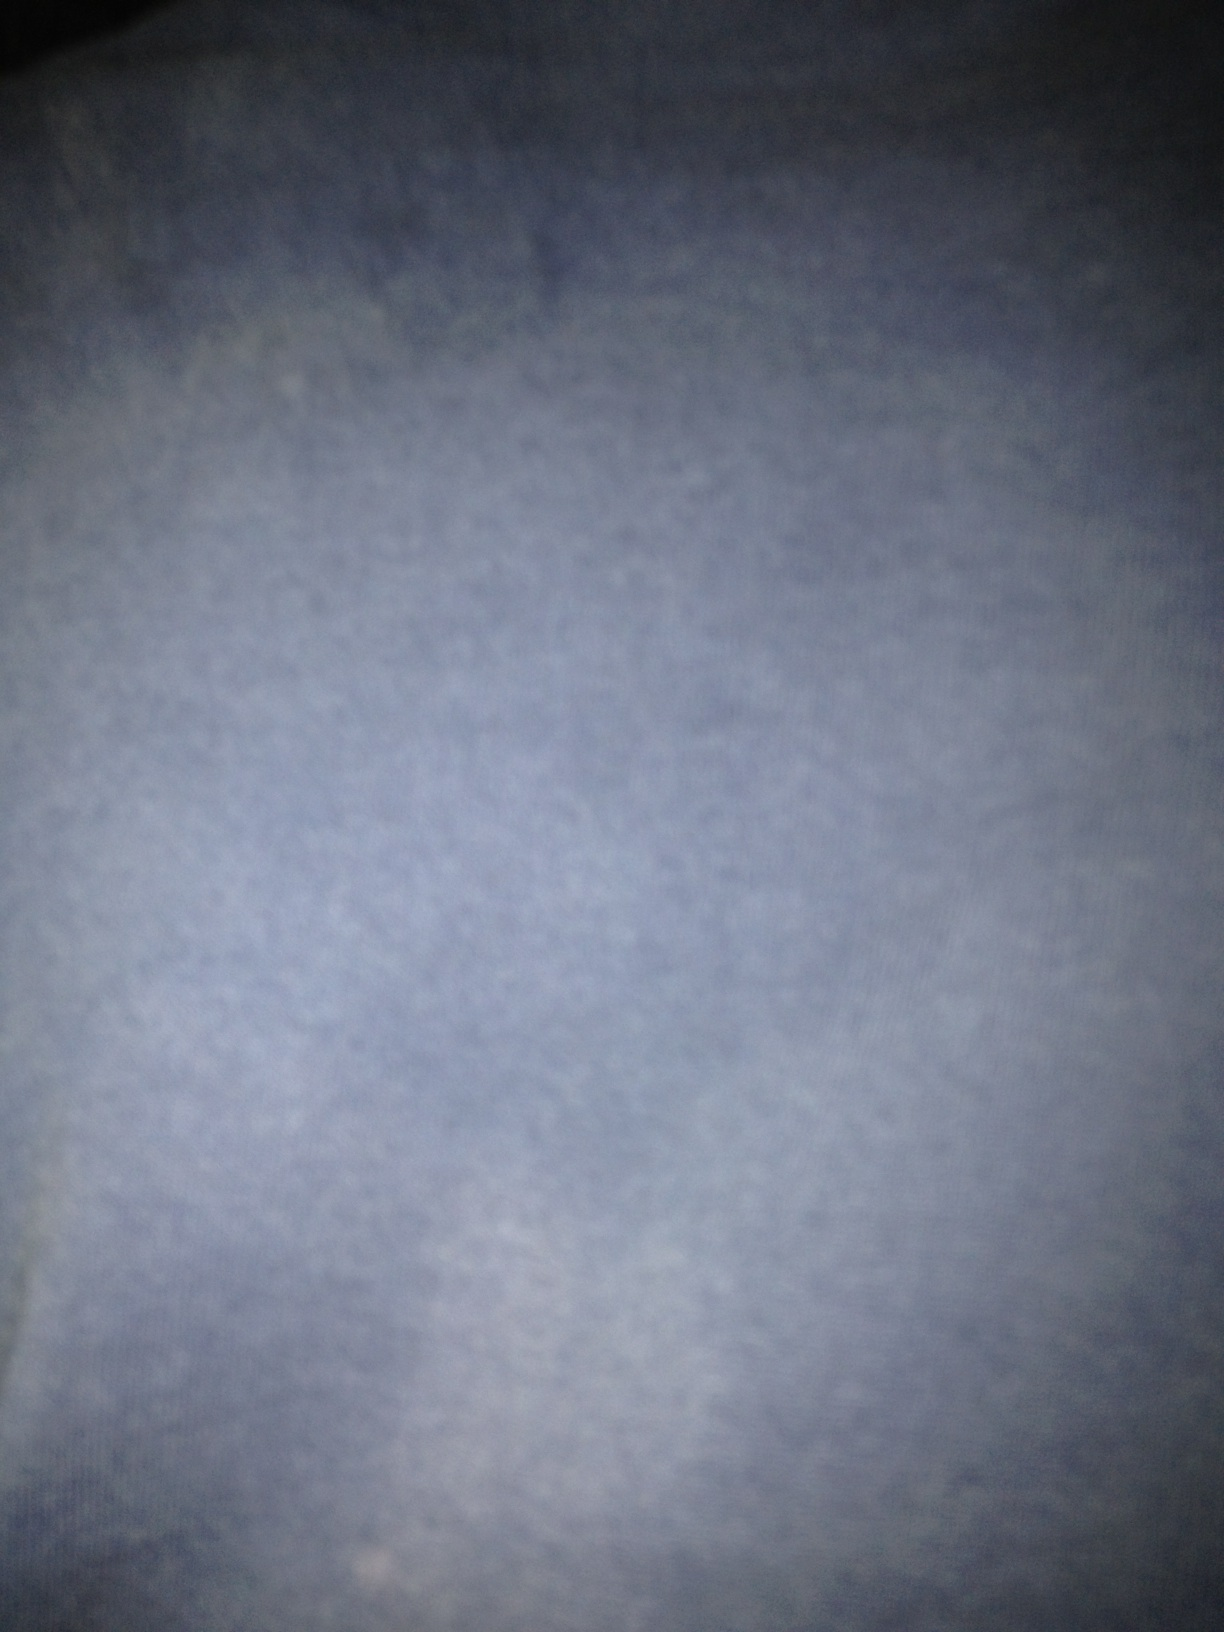Can you describe any detail that might indicate what is shown in the image? The image is too blurred to make out any specific details or objects. It appears to have a uniform texture that might suggest a close-up view of a surface, but nothing more conclusive can be determined without clearer visual information. 